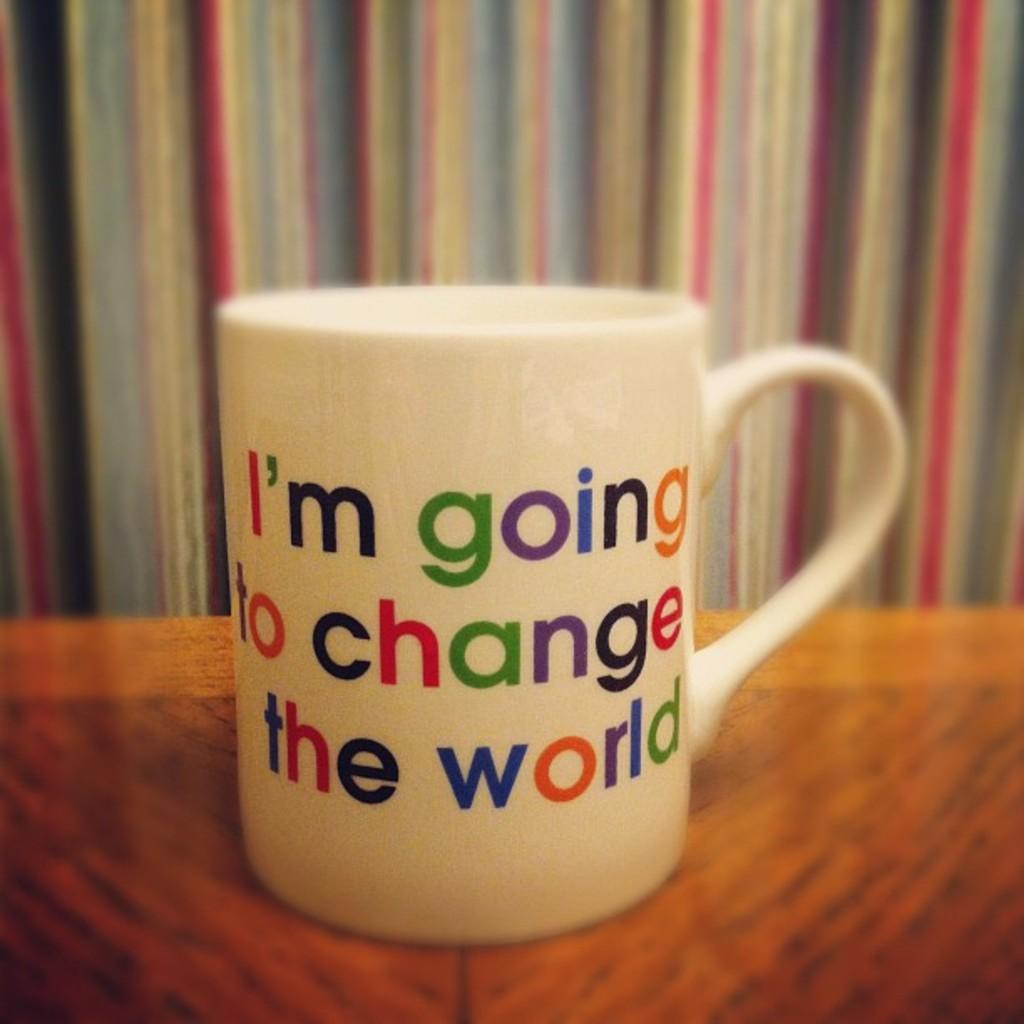What is the main object in the image? There is a mug in the image. What type of sun can be seen on the top of the mug in the image? There is no sun present on the mug or in the image. 